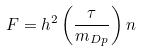Convert formula to latex. <formula><loc_0><loc_0><loc_500><loc_500>F = h ^ { 2 } \left ( \frac { \tau } { m _ { D p } } \right ) n</formula> 